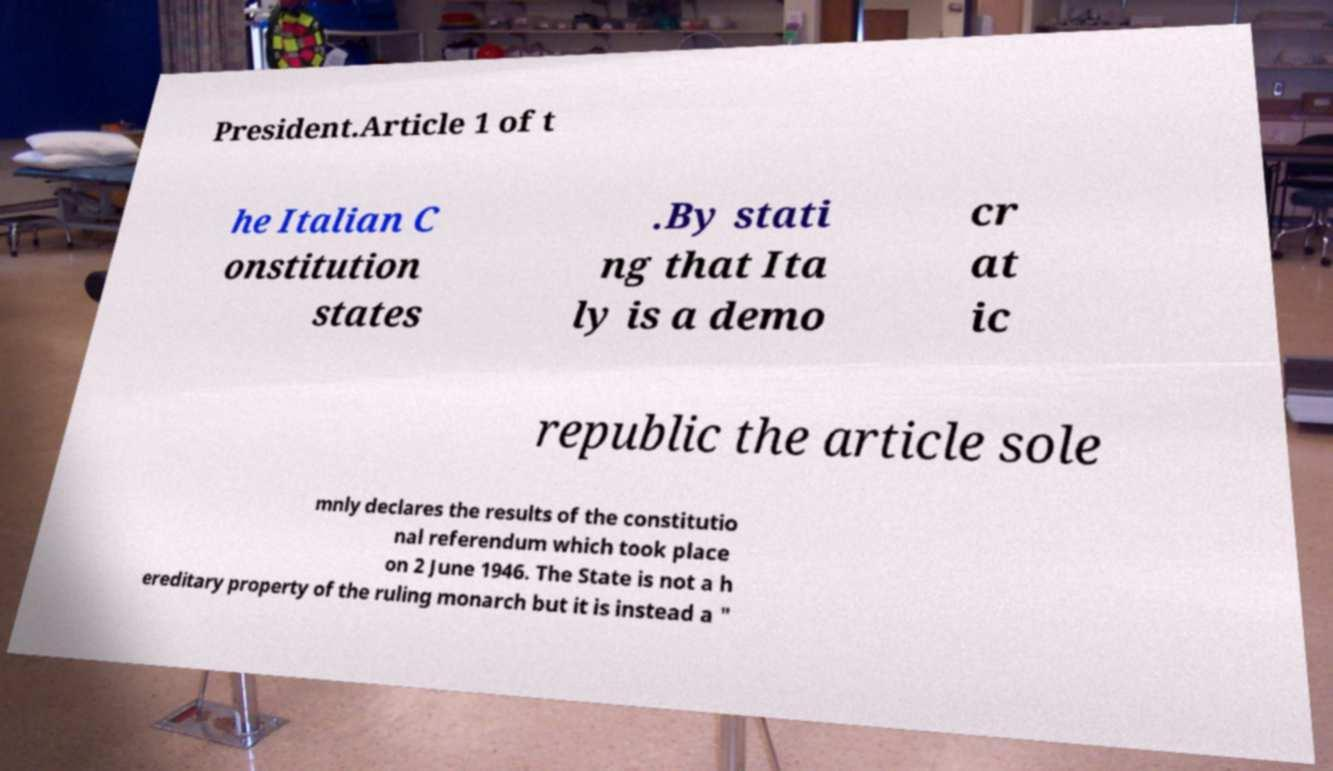Could you assist in decoding the text presented in this image and type it out clearly? President.Article 1 of t he Italian C onstitution states .By stati ng that Ita ly is a demo cr at ic republic the article sole mnly declares the results of the constitutio nal referendum which took place on 2 June 1946. The State is not a h ereditary property of the ruling monarch but it is instead a " 